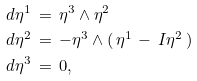Convert formula to latex. <formula><loc_0><loc_0><loc_500><loc_500>d \eta ^ { 1 } \, & = \, \eta ^ { 3 } \wedge \eta ^ { 2 } \\ d \eta ^ { 2 } \, & = \, - \eta ^ { 3 } \wedge ( \, \eta ^ { 1 } \, - \, I \eta ^ { 2 } \, ) \\ d \eta ^ { 3 } \, & = \, 0 ,</formula> 